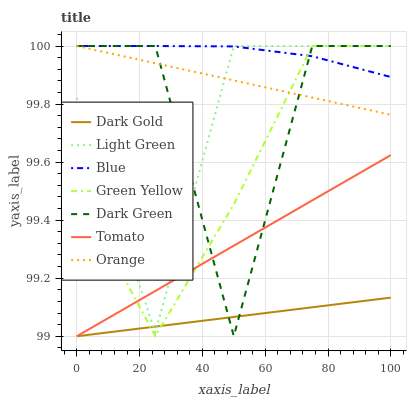Does Tomato have the minimum area under the curve?
Answer yes or no. No. Does Tomato have the maximum area under the curve?
Answer yes or no. No. Is Dark Gold the smoothest?
Answer yes or no. No. Is Dark Gold the roughest?
Answer yes or no. No. Does Light Green have the lowest value?
Answer yes or no. No. Does Tomato have the highest value?
Answer yes or no. No. Is Tomato less than Orange?
Answer yes or no. Yes. Is Blue greater than Dark Gold?
Answer yes or no. Yes. Does Tomato intersect Orange?
Answer yes or no. No. 